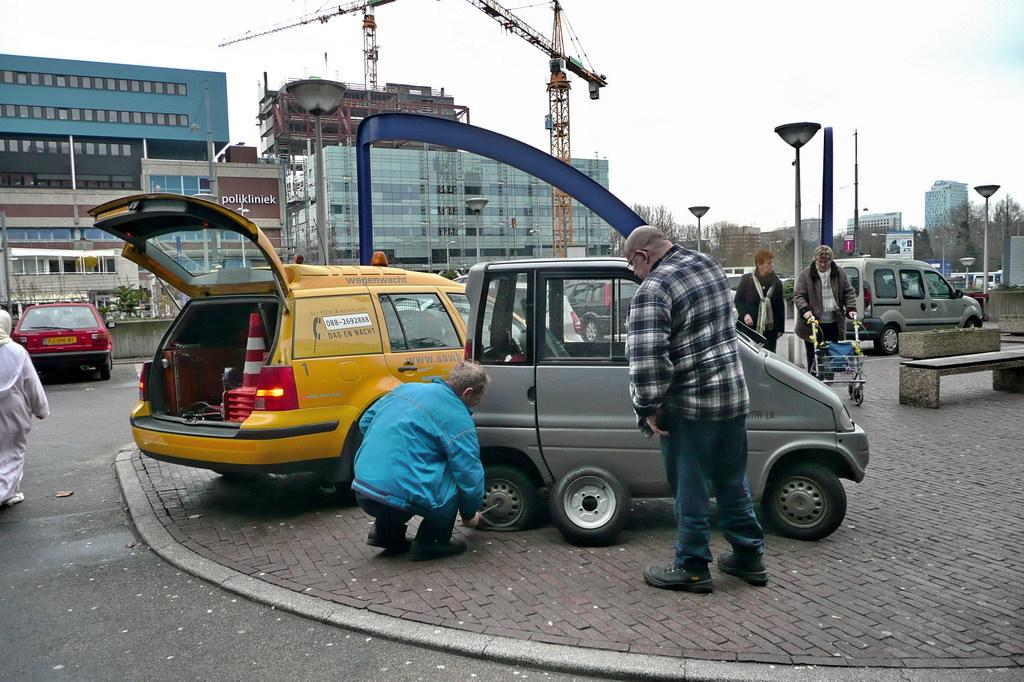<image>
Provide a brief description of the given image. The yellow roadside assistance vehicle seen beside the man changing the tire says wegenwacht. 